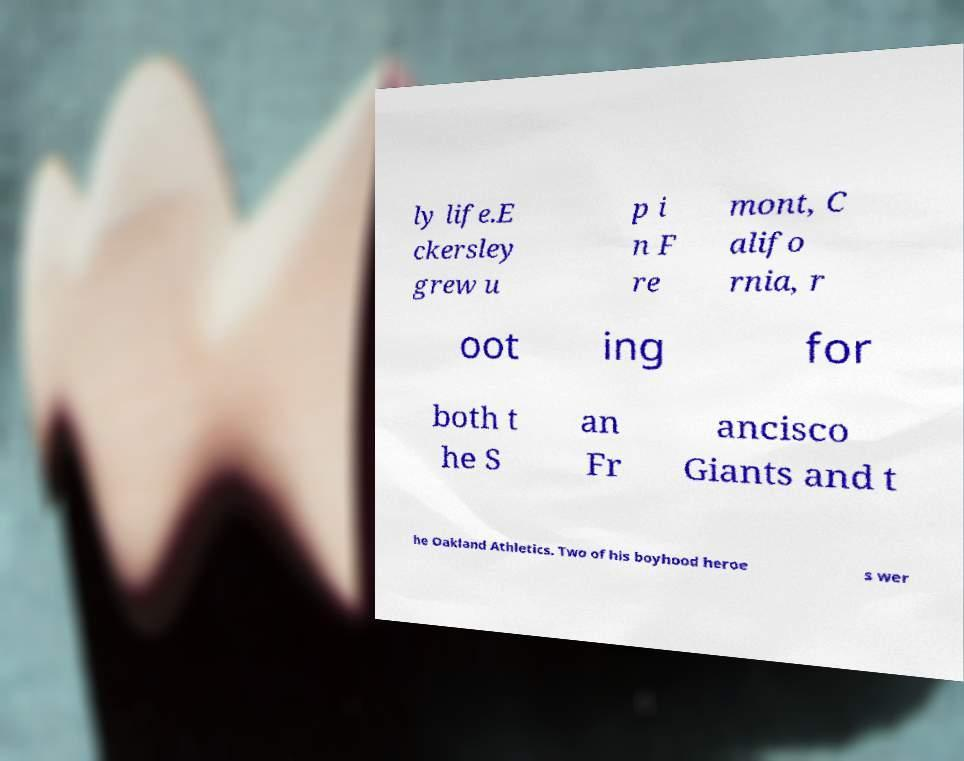Could you assist in decoding the text presented in this image and type it out clearly? ly life.E ckersley grew u p i n F re mont, C alifo rnia, r oot ing for both t he S an Fr ancisco Giants and t he Oakland Athletics. Two of his boyhood heroe s wer 